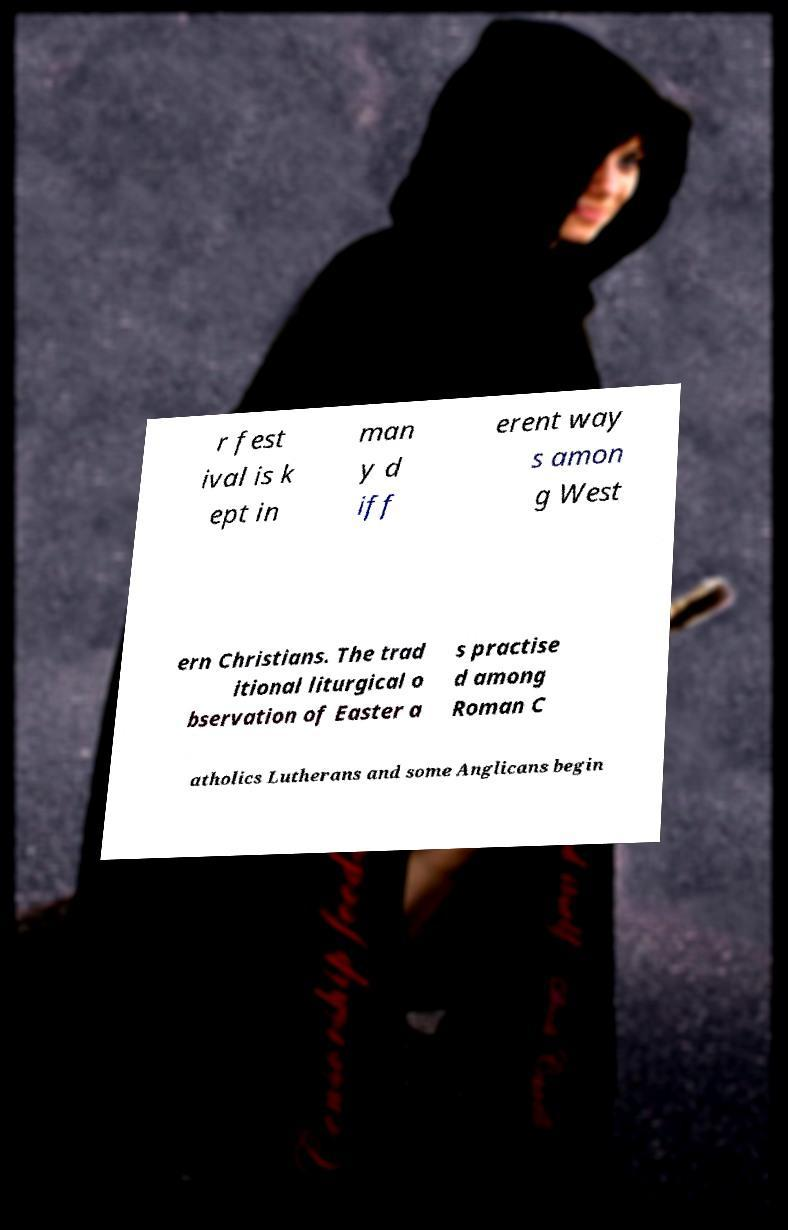What messages or text are displayed in this image? I need them in a readable, typed format. r fest ival is k ept in man y d iff erent way s amon g West ern Christians. The trad itional liturgical o bservation of Easter a s practise d among Roman C atholics Lutherans and some Anglicans begin 